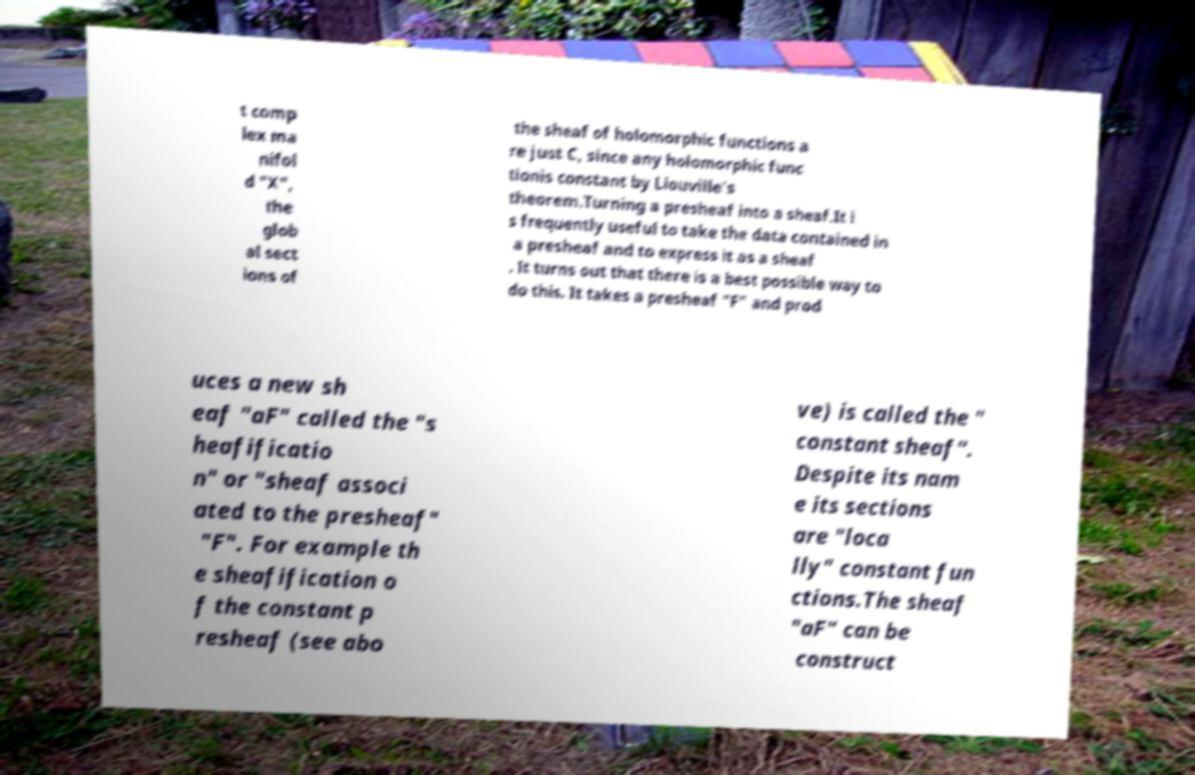Please read and relay the text visible in this image. What does it say? t comp lex ma nifol d "X", the glob al sect ions of the sheaf of holomorphic functions a re just C, since any holomorphic func tionis constant by Liouville's theorem.Turning a presheaf into a sheaf.It i s frequently useful to take the data contained in a presheaf and to express it as a sheaf . It turns out that there is a best possible way to do this. It takes a presheaf "F" and prod uces a new sh eaf "aF" called the "s heafificatio n" or "sheaf associ ated to the presheaf" "F". For example th e sheafification o f the constant p resheaf (see abo ve) is called the " constant sheaf". Despite its nam e its sections are "loca lly" constant fun ctions.The sheaf "aF" can be construct 